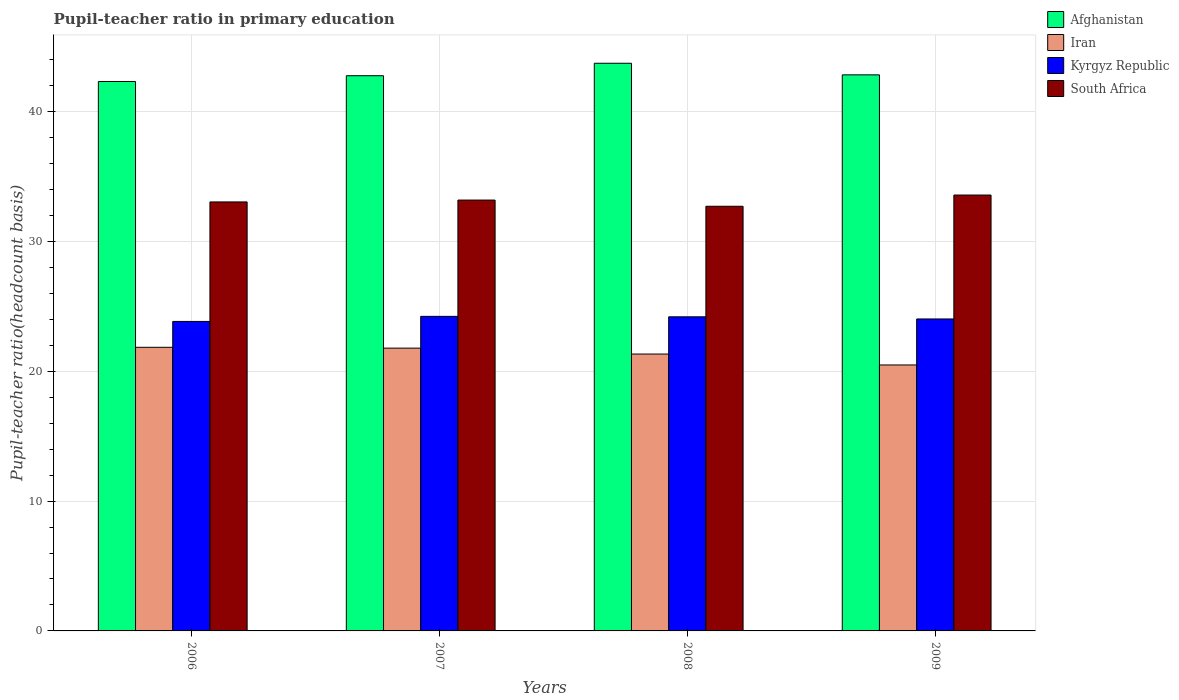How many different coloured bars are there?
Your response must be concise. 4. Are the number of bars per tick equal to the number of legend labels?
Offer a terse response. Yes. How many bars are there on the 3rd tick from the left?
Give a very brief answer. 4. How many bars are there on the 1st tick from the right?
Keep it short and to the point. 4. What is the label of the 3rd group of bars from the left?
Your response must be concise. 2008. What is the pupil-teacher ratio in primary education in South Africa in 2008?
Provide a succinct answer. 32.71. Across all years, what is the maximum pupil-teacher ratio in primary education in Kyrgyz Republic?
Provide a short and direct response. 24.23. Across all years, what is the minimum pupil-teacher ratio in primary education in Iran?
Keep it short and to the point. 20.49. What is the total pupil-teacher ratio in primary education in Afghanistan in the graph?
Provide a short and direct response. 171.66. What is the difference between the pupil-teacher ratio in primary education in Afghanistan in 2006 and that in 2008?
Your answer should be very brief. -1.4. What is the difference between the pupil-teacher ratio in primary education in Iran in 2008 and the pupil-teacher ratio in primary education in South Africa in 2006?
Offer a very short reply. -11.72. What is the average pupil-teacher ratio in primary education in South Africa per year?
Keep it short and to the point. 33.13. In the year 2008, what is the difference between the pupil-teacher ratio in primary education in Afghanistan and pupil-teacher ratio in primary education in South Africa?
Offer a very short reply. 11.02. In how many years, is the pupil-teacher ratio in primary education in Kyrgyz Republic greater than 16?
Keep it short and to the point. 4. What is the ratio of the pupil-teacher ratio in primary education in Iran in 2007 to that in 2009?
Make the answer very short. 1.06. Is the difference between the pupil-teacher ratio in primary education in Afghanistan in 2007 and 2008 greater than the difference between the pupil-teacher ratio in primary education in South Africa in 2007 and 2008?
Provide a short and direct response. No. What is the difference between the highest and the second highest pupil-teacher ratio in primary education in Kyrgyz Republic?
Offer a very short reply. 0.03. What is the difference between the highest and the lowest pupil-teacher ratio in primary education in Afghanistan?
Your answer should be compact. 1.4. In how many years, is the pupil-teacher ratio in primary education in South Africa greater than the average pupil-teacher ratio in primary education in South Africa taken over all years?
Provide a short and direct response. 2. Is the sum of the pupil-teacher ratio in primary education in South Africa in 2007 and 2008 greater than the maximum pupil-teacher ratio in primary education in Iran across all years?
Your answer should be very brief. Yes. Is it the case that in every year, the sum of the pupil-teacher ratio in primary education in Kyrgyz Republic and pupil-teacher ratio in primary education in Afghanistan is greater than the sum of pupil-teacher ratio in primary education in Iran and pupil-teacher ratio in primary education in South Africa?
Offer a terse response. Yes. What does the 2nd bar from the left in 2006 represents?
Provide a succinct answer. Iran. What does the 1st bar from the right in 2008 represents?
Offer a terse response. South Africa. Is it the case that in every year, the sum of the pupil-teacher ratio in primary education in Afghanistan and pupil-teacher ratio in primary education in South Africa is greater than the pupil-teacher ratio in primary education in Kyrgyz Republic?
Your response must be concise. Yes. How many bars are there?
Provide a short and direct response. 16. What is the difference between two consecutive major ticks on the Y-axis?
Provide a succinct answer. 10. Are the values on the major ticks of Y-axis written in scientific E-notation?
Keep it short and to the point. No. Does the graph contain any zero values?
Provide a succinct answer. No. How many legend labels are there?
Your response must be concise. 4. How are the legend labels stacked?
Your answer should be compact. Vertical. What is the title of the graph?
Make the answer very short. Pupil-teacher ratio in primary education. Does "Nepal" appear as one of the legend labels in the graph?
Keep it short and to the point. No. What is the label or title of the Y-axis?
Offer a very short reply. Pupil-teacher ratio(headcount basis). What is the Pupil-teacher ratio(headcount basis) in Afghanistan in 2006?
Give a very brief answer. 42.33. What is the Pupil-teacher ratio(headcount basis) of Iran in 2006?
Provide a succinct answer. 21.85. What is the Pupil-teacher ratio(headcount basis) of Kyrgyz Republic in 2006?
Your response must be concise. 23.84. What is the Pupil-teacher ratio(headcount basis) of South Africa in 2006?
Provide a succinct answer. 33.05. What is the Pupil-teacher ratio(headcount basis) of Afghanistan in 2007?
Provide a short and direct response. 42.77. What is the Pupil-teacher ratio(headcount basis) of Iran in 2007?
Make the answer very short. 21.79. What is the Pupil-teacher ratio(headcount basis) in Kyrgyz Republic in 2007?
Provide a succinct answer. 24.23. What is the Pupil-teacher ratio(headcount basis) of South Africa in 2007?
Make the answer very short. 33.19. What is the Pupil-teacher ratio(headcount basis) in Afghanistan in 2008?
Keep it short and to the point. 43.73. What is the Pupil-teacher ratio(headcount basis) of Iran in 2008?
Provide a succinct answer. 21.33. What is the Pupil-teacher ratio(headcount basis) of Kyrgyz Republic in 2008?
Provide a short and direct response. 24.2. What is the Pupil-teacher ratio(headcount basis) of South Africa in 2008?
Keep it short and to the point. 32.71. What is the Pupil-teacher ratio(headcount basis) in Afghanistan in 2009?
Give a very brief answer. 42.84. What is the Pupil-teacher ratio(headcount basis) in Iran in 2009?
Offer a terse response. 20.49. What is the Pupil-teacher ratio(headcount basis) in Kyrgyz Republic in 2009?
Provide a succinct answer. 24.03. What is the Pupil-teacher ratio(headcount basis) of South Africa in 2009?
Offer a terse response. 33.58. Across all years, what is the maximum Pupil-teacher ratio(headcount basis) in Afghanistan?
Your response must be concise. 43.73. Across all years, what is the maximum Pupil-teacher ratio(headcount basis) in Iran?
Make the answer very short. 21.85. Across all years, what is the maximum Pupil-teacher ratio(headcount basis) in Kyrgyz Republic?
Give a very brief answer. 24.23. Across all years, what is the maximum Pupil-teacher ratio(headcount basis) in South Africa?
Keep it short and to the point. 33.58. Across all years, what is the minimum Pupil-teacher ratio(headcount basis) of Afghanistan?
Your answer should be very brief. 42.33. Across all years, what is the minimum Pupil-teacher ratio(headcount basis) in Iran?
Provide a short and direct response. 20.49. Across all years, what is the minimum Pupil-teacher ratio(headcount basis) in Kyrgyz Republic?
Ensure brevity in your answer.  23.84. Across all years, what is the minimum Pupil-teacher ratio(headcount basis) of South Africa?
Give a very brief answer. 32.71. What is the total Pupil-teacher ratio(headcount basis) in Afghanistan in the graph?
Your answer should be very brief. 171.66. What is the total Pupil-teacher ratio(headcount basis) in Iran in the graph?
Provide a short and direct response. 85.45. What is the total Pupil-teacher ratio(headcount basis) in Kyrgyz Republic in the graph?
Provide a short and direct response. 96.3. What is the total Pupil-teacher ratio(headcount basis) in South Africa in the graph?
Keep it short and to the point. 132.53. What is the difference between the Pupil-teacher ratio(headcount basis) of Afghanistan in 2006 and that in 2007?
Make the answer very short. -0.44. What is the difference between the Pupil-teacher ratio(headcount basis) of Iran in 2006 and that in 2007?
Make the answer very short. 0.06. What is the difference between the Pupil-teacher ratio(headcount basis) in Kyrgyz Republic in 2006 and that in 2007?
Your answer should be compact. -0.39. What is the difference between the Pupil-teacher ratio(headcount basis) in South Africa in 2006 and that in 2007?
Provide a succinct answer. -0.14. What is the difference between the Pupil-teacher ratio(headcount basis) of Afghanistan in 2006 and that in 2008?
Provide a succinct answer. -1.4. What is the difference between the Pupil-teacher ratio(headcount basis) of Iran in 2006 and that in 2008?
Your answer should be compact. 0.52. What is the difference between the Pupil-teacher ratio(headcount basis) of Kyrgyz Republic in 2006 and that in 2008?
Your answer should be very brief. -0.36. What is the difference between the Pupil-teacher ratio(headcount basis) in South Africa in 2006 and that in 2008?
Give a very brief answer. 0.33. What is the difference between the Pupil-teacher ratio(headcount basis) of Afghanistan in 2006 and that in 2009?
Offer a terse response. -0.51. What is the difference between the Pupil-teacher ratio(headcount basis) in Iran in 2006 and that in 2009?
Offer a very short reply. 1.36. What is the difference between the Pupil-teacher ratio(headcount basis) of Kyrgyz Republic in 2006 and that in 2009?
Ensure brevity in your answer.  -0.19. What is the difference between the Pupil-teacher ratio(headcount basis) in South Africa in 2006 and that in 2009?
Your answer should be very brief. -0.53. What is the difference between the Pupil-teacher ratio(headcount basis) in Afghanistan in 2007 and that in 2008?
Offer a very short reply. -0.96. What is the difference between the Pupil-teacher ratio(headcount basis) in Iran in 2007 and that in 2008?
Ensure brevity in your answer.  0.46. What is the difference between the Pupil-teacher ratio(headcount basis) in Kyrgyz Republic in 2007 and that in 2008?
Provide a short and direct response. 0.03. What is the difference between the Pupil-teacher ratio(headcount basis) of South Africa in 2007 and that in 2008?
Your answer should be very brief. 0.48. What is the difference between the Pupil-teacher ratio(headcount basis) in Afghanistan in 2007 and that in 2009?
Your response must be concise. -0.07. What is the difference between the Pupil-teacher ratio(headcount basis) in Iran in 2007 and that in 2009?
Give a very brief answer. 1.3. What is the difference between the Pupil-teacher ratio(headcount basis) in Kyrgyz Republic in 2007 and that in 2009?
Your response must be concise. 0.2. What is the difference between the Pupil-teacher ratio(headcount basis) of South Africa in 2007 and that in 2009?
Ensure brevity in your answer.  -0.39. What is the difference between the Pupil-teacher ratio(headcount basis) of Afghanistan in 2008 and that in 2009?
Provide a succinct answer. 0.89. What is the difference between the Pupil-teacher ratio(headcount basis) of Iran in 2008 and that in 2009?
Offer a very short reply. 0.84. What is the difference between the Pupil-teacher ratio(headcount basis) of Kyrgyz Republic in 2008 and that in 2009?
Give a very brief answer. 0.17. What is the difference between the Pupil-teacher ratio(headcount basis) in South Africa in 2008 and that in 2009?
Your response must be concise. -0.87. What is the difference between the Pupil-teacher ratio(headcount basis) in Afghanistan in 2006 and the Pupil-teacher ratio(headcount basis) in Iran in 2007?
Your answer should be compact. 20.54. What is the difference between the Pupil-teacher ratio(headcount basis) of Afghanistan in 2006 and the Pupil-teacher ratio(headcount basis) of Kyrgyz Republic in 2007?
Provide a short and direct response. 18.09. What is the difference between the Pupil-teacher ratio(headcount basis) of Afghanistan in 2006 and the Pupil-teacher ratio(headcount basis) of South Africa in 2007?
Your answer should be compact. 9.13. What is the difference between the Pupil-teacher ratio(headcount basis) in Iran in 2006 and the Pupil-teacher ratio(headcount basis) in Kyrgyz Republic in 2007?
Your response must be concise. -2.38. What is the difference between the Pupil-teacher ratio(headcount basis) of Iran in 2006 and the Pupil-teacher ratio(headcount basis) of South Africa in 2007?
Make the answer very short. -11.34. What is the difference between the Pupil-teacher ratio(headcount basis) in Kyrgyz Republic in 2006 and the Pupil-teacher ratio(headcount basis) in South Africa in 2007?
Your answer should be compact. -9.35. What is the difference between the Pupil-teacher ratio(headcount basis) in Afghanistan in 2006 and the Pupil-teacher ratio(headcount basis) in Iran in 2008?
Your answer should be very brief. 21. What is the difference between the Pupil-teacher ratio(headcount basis) in Afghanistan in 2006 and the Pupil-teacher ratio(headcount basis) in Kyrgyz Republic in 2008?
Give a very brief answer. 18.13. What is the difference between the Pupil-teacher ratio(headcount basis) in Afghanistan in 2006 and the Pupil-teacher ratio(headcount basis) in South Africa in 2008?
Your response must be concise. 9.61. What is the difference between the Pupil-teacher ratio(headcount basis) of Iran in 2006 and the Pupil-teacher ratio(headcount basis) of Kyrgyz Republic in 2008?
Your answer should be compact. -2.35. What is the difference between the Pupil-teacher ratio(headcount basis) of Iran in 2006 and the Pupil-teacher ratio(headcount basis) of South Africa in 2008?
Your answer should be very brief. -10.86. What is the difference between the Pupil-teacher ratio(headcount basis) of Kyrgyz Republic in 2006 and the Pupil-teacher ratio(headcount basis) of South Africa in 2008?
Your answer should be very brief. -8.87. What is the difference between the Pupil-teacher ratio(headcount basis) in Afghanistan in 2006 and the Pupil-teacher ratio(headcount basis) in Iran in 2009?
Keep it short and to the point. 21.84. What is the difference between the Pupil-teacher ratio(headcount basis) of Afghanistan in 2006 and the Pupil-teacher ratio(headcount basis) of Kyrgyz Republic in 2009?
Make the answer very short. 18.29. What is the difference between the Pupil-teacher ratio(headcount basis) of Afghanistan in 2006 and the Pupil-teacher ratio(headcount basis) of South Africa in 2009?
Provide a succinct answer. 8.75. What is the difference between the Pupil-teacher ratio(headcount basis) in Iran in 2006 and the Pupil-teacher ratio(headcount basis) in Kyrgyz Republic in 2009?
Offer a very short reply. -2.18. What is the difference between the Pupil-teacher ratio(headcount basis) in Iran in 2006 and the Pupil-teacher ratio(headcount basis) in South Africa in 2009?
Your answer should be compact. -11.73. What is the difference between the Pupil-teacher ratio(headcount basis) of Kyrgyz Republic in 2006 and the Pupil-teacher ratio(headcount basis) of South Africa in 2009?
Make the answer very short. -9.74. What is the difference between the Pupil-teacher ratio(headcount basis) of Afghanistan in 2007 and the Pupil-teacher ratio(headcount basis) of Iran in 2008?
Give a very brief answer. 21.44. What is the difference between the Pupil-teacher ratio(headcount basis) of Afghanistan in 2007 and the Pupil-teacher ratio(headcount basis) of Kyrgyz Republic in 2008?
Your response must be concise. 18.57. What is the difference between the Pupil-teacher ratio(headcount basis) of Afghanistan in 2007 and the Pupil-teacher ratio(headcount basis) of South Africa in 2008?
Give a very brief answer. 10.06. What is the difference between the Pupil-teacher ratio(headcount basis) in Iran in 2007 and the Pupil-teacher ratio(headcount basis) in Kyrgyz Republic in 2008?
Ensure brevity in your answer.  -2.41. What is the difference between the Pupil-teacher ratio(headcount basis) in Iran in 2007 and the Pupil-teacher ratio(headcount basis) in South Africa in 2008?
Make the answer very short. -10.93. What is the difference between the Pupil-teacher ratio(headcount basis) in Kyrgyz Republic in 2007 and the Pupil-teacher ratio(headcount basis) in South Africa in 2008?
Offer a very short reply. -8.48. What is the difference between the Pupil-teacher ratio(headcount basis) of Afghanistan in 2007 and the Pupil-teacher ratio(headcount basis) of Iran in 2009?
Give a very brief answer. 22.28. What is the difference between the Pupil-teacher ratio(headcount basis) of Afghanistan in 2007 and the Pupil-teacher ratio(headcount basis) of Kyrgyz Republic in 2009?
Provide a succinct answer. 18.74. What is the difference between the Pupil-teacher ratio(headcount basis) in Afghanistan in 2007 and the Pupil-teacher ratio(headcount basis) in South Africa in 2009?
Your answer should be very brief. 9.19. What is the difference between the Pupil-teacher ratio(headcount basis) in Iran in 2007 and the Pupil-teacher ratio(headcount basis) in Kyrgyz Republic in 2009?
Your answer should be very brief. -2.25. What is the difference between the Pupil-teacher ratio(headcount basis) in Iran in 2007 and the Pupil-teacher ratio(headcount basis) in South Africa in 2009?
Provide a short and direct response. -11.79. What is the difference between the Pupil-teacher ratio(headcount basis) of Kyrgyz Republic in 2007 and the Pupil-teacher ratio(headcount basis) of South Africa in 2009?
Provide a succinct answer. -9.35. What is the difference between the Pupil-teacher ratio(headcount basis) of Afghanistan in 2008 and the Pupil-teacher ratio(headcount basis) of Iran in 2009?
Offer a terse response. 23.24. What is the difference between the Pupil-teacher ratio(headcount basis) of Afghanistan in 2008 and the Pupil-teacher ratio(headcount basis) of Kyrgyz Republic in 2009?
Your answer should be very brief. 19.7. What is the difference between the Pupil-teacher ratio(headcount basis) in Afghanistan in 2008 and the Pupil-teacher ratio(headcount basis) in South Africa in 2009?
Provide a succinct answer. 10.15. What is the difference between the Pupil-teacher ratio(headcount basis) of Iran in 2008 and the Pupil-teacher ratio(headcount basis) of Kyrgyz Republic in 2009?
Your answer should be very brief. -2.7. What is the difference between the Pupil-teacher ratio(headcount basis) of Iran in 2008 and the Pupil-teacher ratio(headcount basis) of South Africa in 2009?
Your answer should be compact. -12.25. What is the difference between the Pupil-teacher ratio(headcount basis) of Kyrgyz Republic in 2008 and the Pupil-teacher ratio(headcount basis) of South Africa in 2009?
Make the answer very short. -9.38. What is the average Pupil-teacher ratio(headcount basis) in Afghanistan per year?
Your answer should be compact. 42.92. What is the average Pupil-teacher ratio(headcount basis) in Iran per year?
Provide a succinct answer. 21.36. What is the average Pupil-teacher ratio(headcount basis) in Kyrgyz Republic per year?
Make the answer very short. 24.08. What is the average Pupil-teacher ratio(headcount basis) in South Africa per year?
Your response must be concise. 33.13. In the year 2006, what is the difference between the Pupil-teacher ratio(headcount basis) of Afghanistan and Pupil-teacher ratio(headcount basis) of Iran?
Give a very brief answer. 20.48. In the year 2006, what is the difference between the Pupil-teacher ratio(headcount basis) of Afghanistan and Pupil-teacher ratio(headcount basis) of Kyrgyz Republic?
Your answer should be compact. 18.48. In the year 2006, what is the difference between the Pupil-teacher ratio(headcount basis) in Afghanistan and Pupil-teacher ratio(headcount basis) in South Africa?
Your answer should be compact. 9.28. In the year 2006, what is the difference between the Pupil-teacher ratio(headcount basis) of Iran and Pupil-teacher ratio(headcount basis) of Kyrgyz Republic?
Ensure brevity in your answer.  -1.99. In the year 2006, what is the difference between the Pupil-teacher ratio(headcount basis) of Iran and Pupil-teacher ratio(headcount basis) of South Africa?
Your answer should be very brief. -11.2. In the year 2006, what is the difference between the Pupil-teacher ratio(headcount basis) in Kyrgyz Republic and Pupil-teacher ratio(headcount basis) in South Africa?
Offer a terse response. -9.21. In the year 2007, what is the difference between the Pupil-teacher ratio(headcount basis) in Afghanistan and Pupil-teacher ratio(headcount basis) in Iran?
Give a very brief answer. 20.99. In the year 2007, what is the difference between the Pupil-teacher ratio(headcount basis) in Afghanistan and Pupil-teacher ratio(headcount basis) in Kyrgyz Republic?
Provide a succinct answer. 18.54. In the year 2007, what is the difference between the Pupil-teacher ratio(headcount basis) of Afghanistan and Pupil-teacher ratio(headcount basis) of South Africa?
Make the answer very short. 9.58. In the year 2007, what is the difference between the Pupil-teacher ratio(headcount basis) in Iran and Pupil-teacher ratio(headcount basis) in Kyrgyz Republic?
Give a very brief answer. -2.45. In the year 2007, what is the difference between the Pupil-teacher ratio(headcount basis) of Iran and Pupil-teacher ratio(headcount basis) of South Africa?
Give a very brief answer. -11.41. In the year 2007, what is the difference between the Pupil-teacher ratio(headcount basis) of Kyrgyz Republic and Pupil-teacher ratio(headcount basis) of South Africa?
Offer a very short reply. -8.96. In the year 2008, what is the difference between the Pupil-teacher ratio(headcount basis) of Afghanistan and Pupil-teacher ratio(headcount basis) of Iran?
Offer a very short reply. 22.4. In the year 2008, what is the difference between the Pupil-teacher ratio(headcount basis) of Afghanistan and Pupil-teacher ratio(headcount basis) of Kyrgyz Republic?
Offer a very short reply. 19.53. In the year 2008, what is the difference between the Pupil-teacher ratio(headcount basis) of Afghanistan and Pupil-teacher ratio(headcount basis) of South Africa?
Give a very brief answer. 11.02. In the year 2008, what is the difference between the Pupil-teacher ratio(headcount basis) in Iran and Pupil-teacher ratio(headcount basis) in Kyrgyz Republic?
Offer a terse response. -2.87. In the year 2008, what is the difference between the Pupil-teacher ratio(headcount basis) in Iran and Pupil-teacher ratio(headcount basis) in South Africa?
Offer a terse response. -11.38. In the year 2008, what is the difference between the Pupil-teacher ratio(headcount basis) in Kyrgyz Republic and Pupil-teacher ratio(headcount basis) in South Africa?
Provide a short and direct response. -8.52. In the year 2009, what is the difference between the Pupil-teacher ratio(headcount basis) of Afghanistan and Pupil-teacher ratio(headcount basis) of Iran?
Provide a succinct answer. 22.35. In the year 2009, what is the difference between the Pupil-teacher ratio(headcount basis) of Afghanistan and Pupil-teacher ratio(headcount basis) of Kyrgyz Republic?
Offer a very short reply. 18.8. In the year 2009, what is the difference between the Pupil-teacher ratio(headcount basis) in Afghanistan and Pupil-teacher ratio(headcount basis) in South Africa?
Keep it short and to the point. 9.26. In the year 2009, what is the difference between the Pupil-teacher ratio(headcount basis) in Iran and Pupil-teacher ratio(headcount basis) in Kyrgyz Republic?
Offer a very short reply. -3.54. In the year 2009, what is the difference between the Pupil-teacher ratio(headcount basis) in Iran and Pupil-teacher ratio(headcount basis) in South Africa?
Make the answer very short. -13.09. In the year 2009, what is the difference between the Pupil-teacher ratio(headcount basis) of Kyrgyz Republic and Pupil-teacher ratio(headcount basis) of South Africa?
Offer a terse response. -9.55. What is the ratio of the Pupil-teacher ratio(headcount basis) of Afghanistan in 2006 to that in 2007?
Provide a succinct answer. 0.99. What is the ratio of the Pupil-teacher ratio(headcount basis) in Iran in 2006 to that in 2007?
Your answer should be very brief. 1. What is the ratio of the Pupil-teacher ratio(headcount basis) of Kyrgyz Republic in 2006 to that in 2007?
Your answer should be compact. 0.98. What is the ratio of the Pupil-teacher ratio(headcount basis) in Afghanistan in 2006 to that in 2008?
Your answer should be compact. 0.97. What is the ratio of the Pupil-teacher ratio(headcount basis) in Iran in 2006 to that in 2008?
Provide a short and direct response. 1.02. What is the ratio of the Pupil-teacher ratio(headcount basis) of Kyrgyz Republic in 2006 to that in 2008?
Offer a very short reply. 0.99. What is the ratio of the Pupil-teacher ratio(headcount basis) of South Africa in 2006 to that in 2008?
Give a very brief answer. 1.01. What is the ratio of the Pupil-teacher ratio(headcount basis) of Iran in 2006 to that in 2009?
Keep it short and to the point. 1.07. What is the ratio of the Pupil-teacher ratio(headcount basis) of Kyrgyz Republic in 2006 to that in 2009?
Your response must be concise. 0.99. What is the ratio of the Pupil-teacher ratio(headcount basis) in South Africa in 2006 to that in 2009?
Offer a very short reply. 0.98. What is the ratio of the Pupil-teacher ratio(headcount basis) of Afghanistan in 2007 to that in 2008?
Keep it short and to the point. 0.98. What is the ratio of the Pupil-teacher ratio(headcount basis) of Iran in 2007 to that in 2008?
Offer a terse response. 1.02. What is the ratio of the Pupil-teacher ratio(headcount basis) of Kyrgyz Republic in 2007 to that in 2008?
Make the answer very short. 1. What is the ratio of the Pupil-teacher ratio(headcount basis) in South Africa in 2007 to that in 2008?
Give a very brief answer. 1.01. What is the ratio of the Pupil-teacher ratio(headcount basis) of Afghanistan in 2007 to that in 2009?
Provide a succinct answer. 1. What is the ratio of the Pupil-teacher ratio(headcount basis) in Iran in 2007 to that in 2009?
Ensure brevity in your answer.  1.06. What is the ratio of the Pupil-teacher ratio(headcount basis) of Kyrgyz Republic in 2007 to that in 2009?
Make the answer very short. 1.01. What is the ratio of the Pupil-teacher ratio(headcount basis) in Afghanistan in 2008 to that in 2009?
Your response must be concise. 1.02. What is the ratio of the Pupil-teacher ratio(headcount basis) in Iran in 2008 to that in 2009?
Offer a very short reply. 1.04. What is the ratio of the Pupil-teacher ratio(headcount basis) in Kyrgyz Republic in 2008 to that in 2009?
Your answer should be very brief. 1.01. What is the ratio of the Pupil-teacher ratio(headcount basis) of South Africa in 2008 to that in 2009?
Your response must be concise. 0.97. What is the difference between the highest and the second highest Pupil-teacher ratio(headcount basis) in Afghanistan?
Keep it short and to the point. 0.89. What is the difference between the highest and the second highest Pupil-teacher ratio(headcount basis) of Iran?
Offer a terse response. 0.06. What is the difference between the highest and the second highest Pupil-teacher ratio(headcount basis) in Kyrgyz Republic?
Make the answer very short. 0.03. What is the difference between the highest and the second highest Pupil-teacher ratio(headcount basis) of South Africa?
Your response must be concise. 0.39. What is the difference between the highest and the lowest Pupil-teacher ratio(headcount basis) of Afghanistan?
Provide a succinct answer. 1.4. What is the difference between the highest and the lowest Pupil-teacher ratio(headcount basis) of Iran?
Ensure brevity in your answer.  1.36. What is the difference between the highest and the lowest Pupil-teacher ratio(headcount basis) in Kyrgyz Republic?
Provide a short and direct response. 0.39. What is the difference between the highest and the lowest Pupil-teacher ratio(headcount basis) of South Africa?
Make the answer very short. 0.87. 